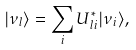<formula> <loc_0><loc_0><loc_500><loc_500>| \nu _ { l } \rangle = \sum _ { i } U ^ { * } _ { l i } | \nu _ { i } \rangle ,</formula> 